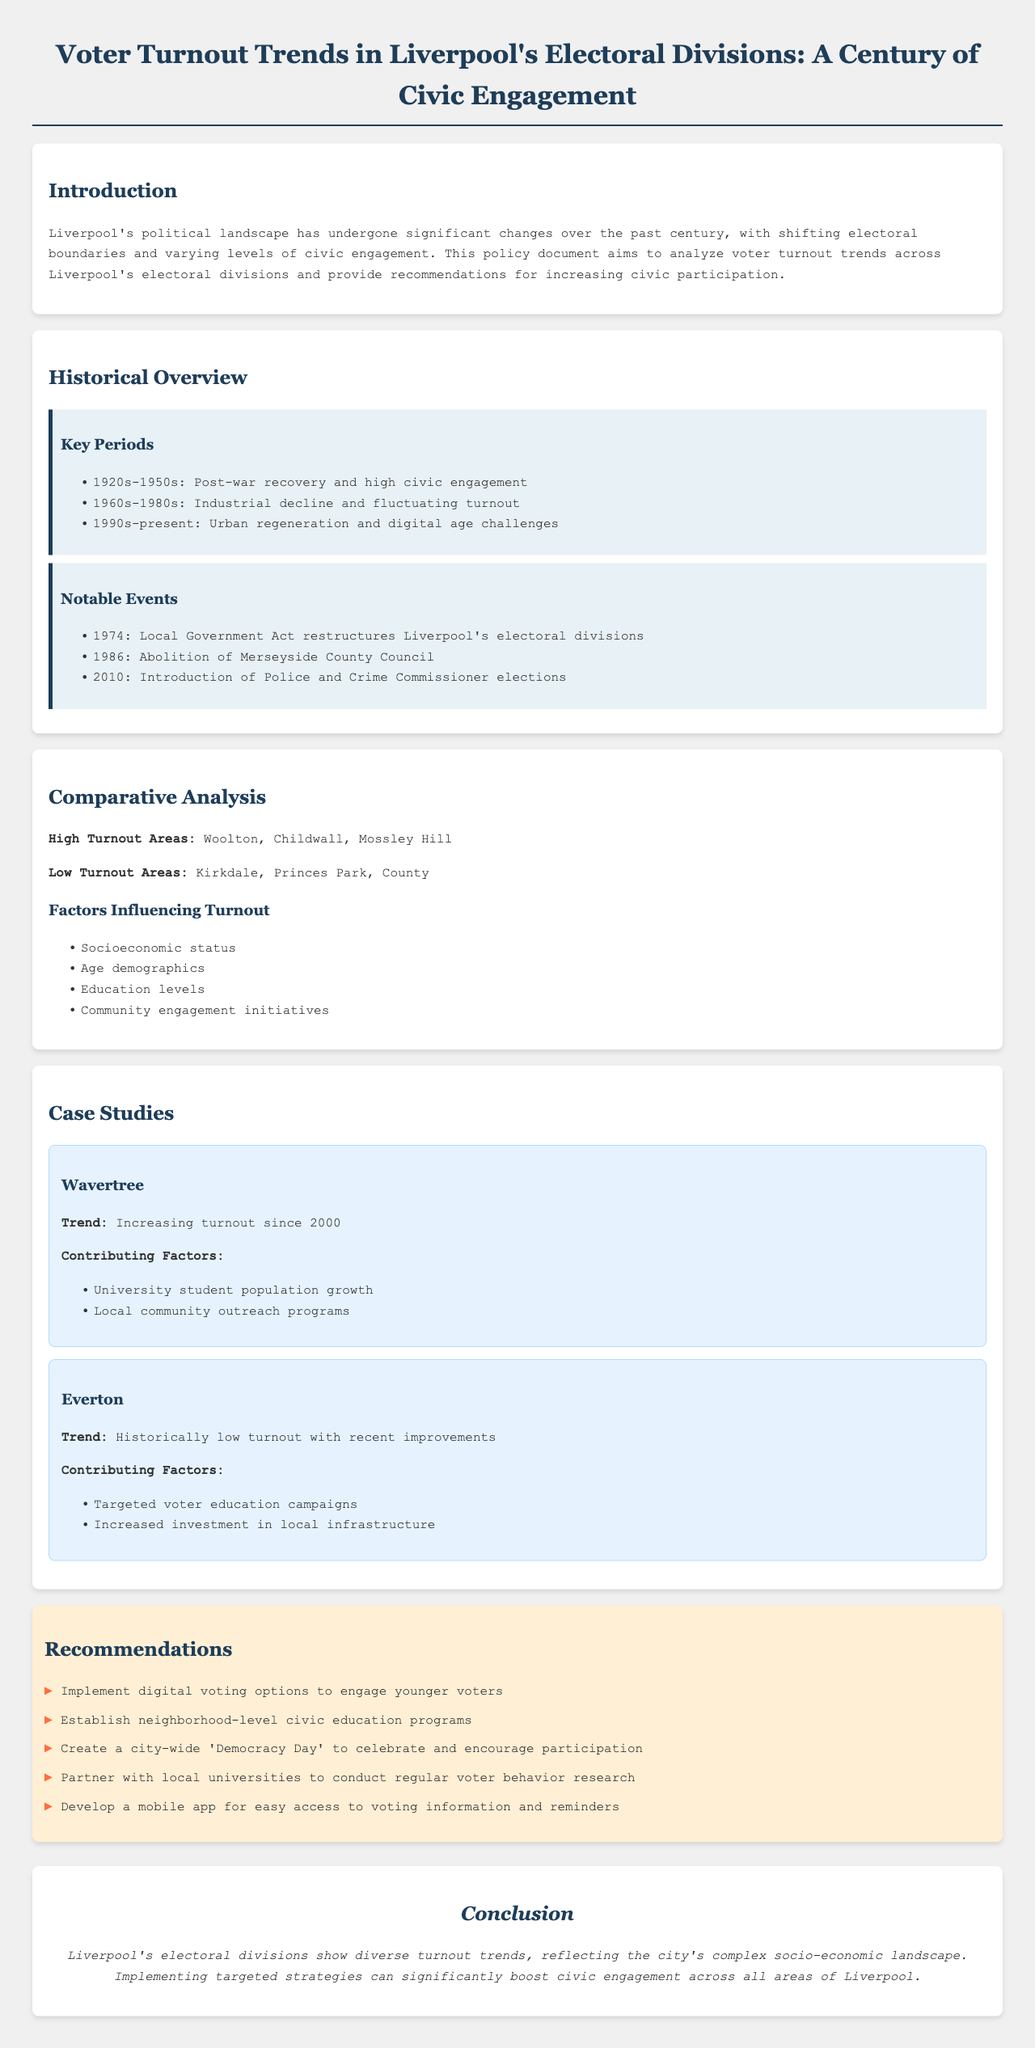What are the high turnout areas in Liverpool? The document lists Woolton, Childwall, and Mossley Hill as high turnout areas.
Answer: Woolton, Childwall, Mossley Hill What are the low turnout areas in Liverpool? The document specifies Kirkdale, Princes Park, and County as low turnout areas.
Answer: Kirkdale, Princes Park, County What period is associated with high civic engagement? The document states that the 1920s-1950s was a period of post-war recovery and high civic engagement.
Answer: 1920s-1950s What year did the Local Government Act restructure Liverpool's electoral divisions? The document mentions that the Local Government Act was enacted in 1974.
Answer: 1974 What trend has been observed in Wavertree since 2000? The document notes an increasing turnout trend in Wavertree since 2000.
Answer: Increasing turnout What is a contributing factor for the low turnout in Everton? According to the document, targeted voter education campaigns have contributed to recent improvements in Everton.
Answer: Targeted voter education campaigns What is one recommendation to engage younger voters? The document recommends implementing digital voting options to engage younger voters.
Answer: Digital voting options Which demographic factor is identified as influencing voter turnout? The document lists age demographics as a factor influencing turnout.
Answer: Age demographics What is the main conclusion of the document? The conclusion emphasizes the importance of implementing targeted strategies to boost civic engagement.
Answer: Targeted strategies to boost civic engagement 